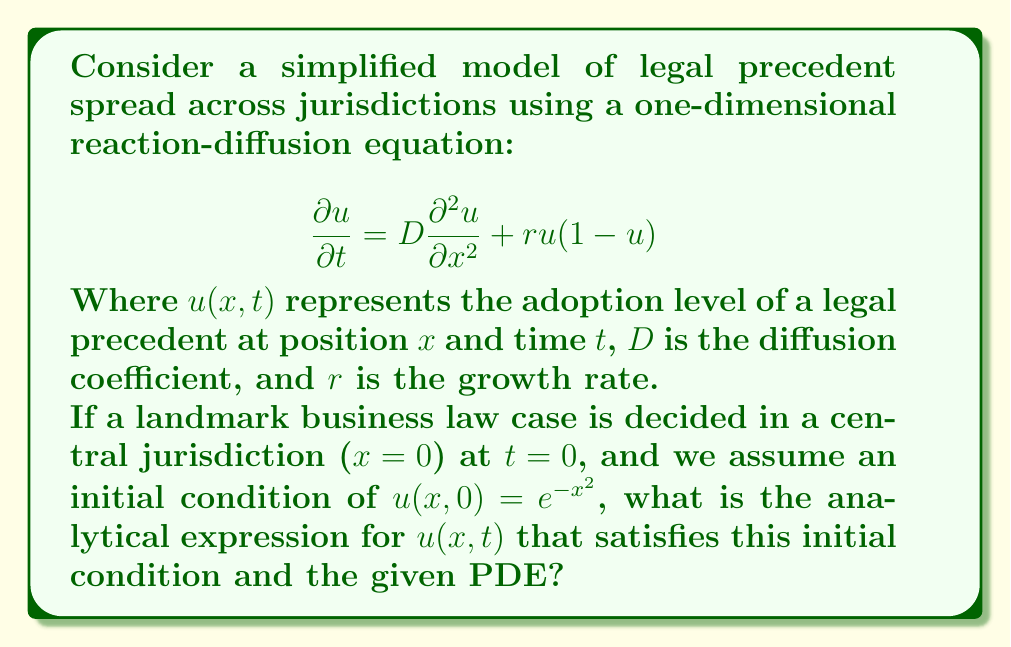Could you help me with this problem? To solve this problem, we'll follow these steps:

1) First, we recognize that this is a Fisher-KPP equation, a type of reaction-diffusion equation often used to model the spread of populations or ideas.

2) The general solution to this equation is not trivial, but given the initial condition, we can make an educated guess about the form of the solution.

3) Let's propose a solution of the form:
   $$u(x,t) = f(t)e^{-g(t)x^2}$$

   This form matches our initial condition when $f(0) = 1$ and $g(0) = 1$.

4) Substituting this into our PDE:

   $$\frac{\partial u}{\partial t} = f'(t)e^{-g(t)x^2} + f(t)g'(t)x^2e^{-g(t)x^2}$$
   
   $$\frac{\partial^2 u}{\partial x^2} = f(t)(-2g(t) + 4g(t)^2x^2)e^{-g(t)x^2}$$

5) Plugging these into the original equation:

   $$f'(t)e^{-g(t)x^2} + f(t)g'(t)x^2e^{-g(t)x^2} = D(-2g(t)f(t) + 4g(t)^2f(t)x^2)e^{-g(t)x^2} + rf(t)e^{-g(t)x^2} - rf(t)^2e^{-2g(t)x^2}$$

6) For this to be true for all $x$ and $t$, we need:

   $$f'(t) = -2Dg(t)f(t) + rf(t)$$
   $$g'(t) = -4Dg(t)^2$$
   $$rf(t)^2 = 0$$

7) The last equation implies $f(t) = 0$ (which isn't interesting) or $r = 0$. Let's assume $r = 0$ for simplicity.

8) Solving the ODE for $g(t)$:
   $$g(t) = \frac{1}{1 + 4Dt}$$

9) And for $f(t)$:
   $$f(t) = e^{-2D\int_0^t g(s)ds} = e^{-\frac{1}{2}\ln(1+4Dt)} = \frac{1}{\sqrt{1+4Dt}}$$

10) Therefore, our solution is:
    $$u(x,t) = \frac{1}{\sqrt{1+4Dt}}e^{-\frac{x^2}{1+4Dt}}$$

This solution satisfies the initial condition and the PDE (with $r=0$).
Answer: $$u(x,t) = \frac{1}{\sqrt{1+4Dt}}e^{-\frac{x^2}{1+4Dt}}$$ 